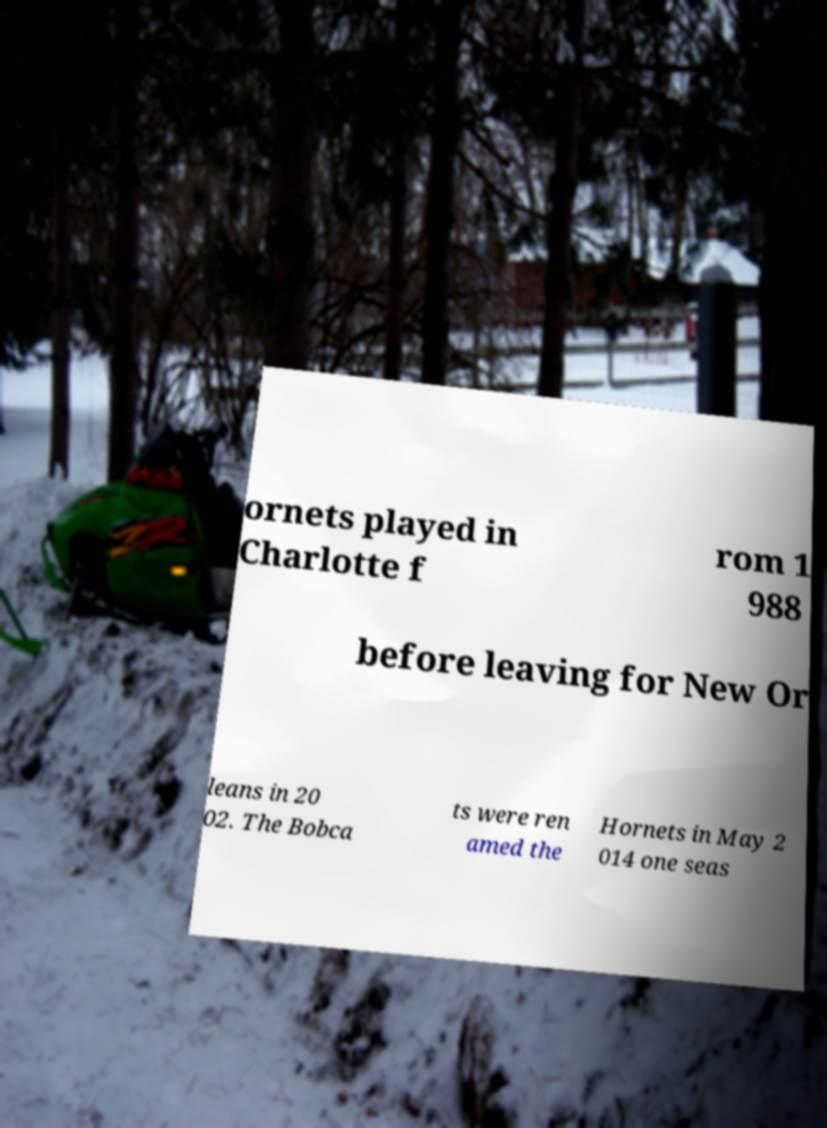Can you accurately transcribe the text from the provided image for me? ornets played in Charlotte f rom 1 988 before leaving for New Or leans in 20 02. The Bobca ts were ren amed the Hornets in May 2 014 one seas 